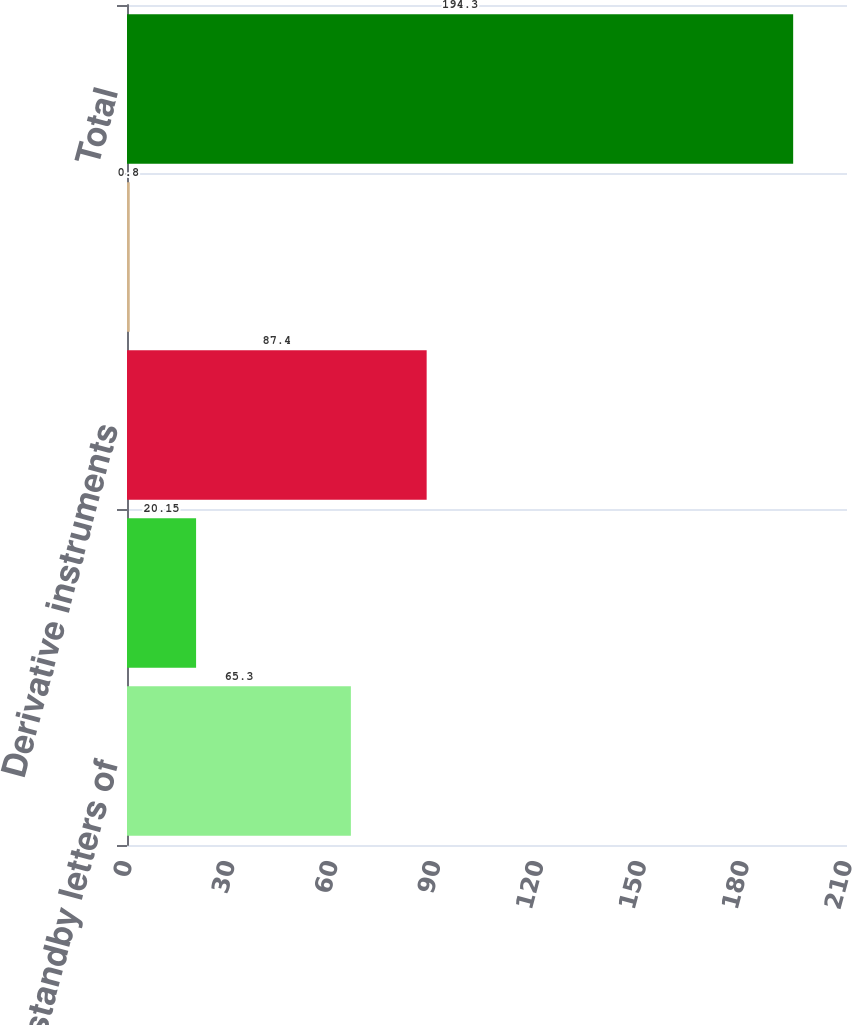<chart> <loc_0><loc_0><loc_500><loc_500><bar_chart><fcel>Financial standby letters of<fcel>Performance guarantees<fcel>Derivative instruments<fcel>Credit card arrangements with<fcel>Total<nl><fcel>65.3<fcel>20.15<fcel>87.4<fcel>0.8<fcel>194.3<nl></chart> 